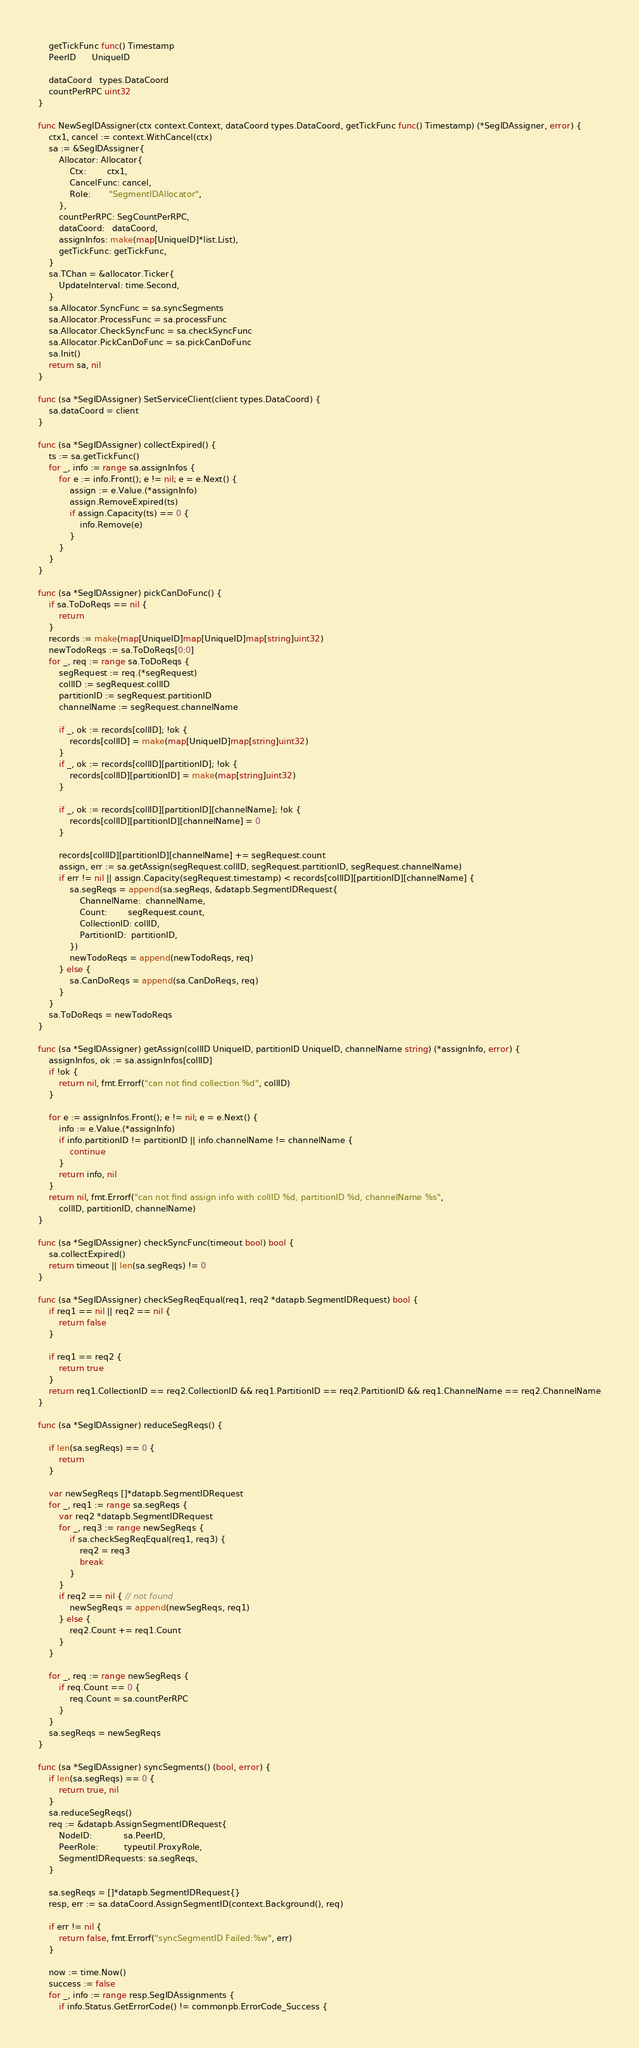Convert code to text. <code><loc_0><loc_0><loc_500><loc_500><_Go_>	getTickFunc func() Timestamp
	PeerID      UniqueID

	dataCoord   types.DataCoord
	countPerRPC uint32
}

func NewSegIDAssigner(ctx context.Context, dataCoord types.DataCoord, getTickFunc func() Timestamp) (*SegIDAssigner, error) {
	ctx1, cancel := context.WithCancel(ctx)
	sa := &SegIDAssigner{
		Allocator: Allocator{
			Ctx:        ctx1,
			CancelFunc: cancel,
			Role:       "SegmentIDAllocator",
		},
		countPerRPC: SegCountPerRPC,
		dataCoord:   dataCoord,
		assignInfos: make(map[UniqueID]*list.List),
		getTickFunc: getTickFunc,
	}
	sa.TChan = &allocator.Ticker{
		UpdateInterval: time.Second,
	}
	sa.Allocator.SyncFunc = sa.syncSegments
	sa.Allocator.ProcessFunc = sa.processFunc
	sa.Allocator.CheckSyncFunc = sa.checkSyncFunc
	sa.Allocator.PickCanDoFunc = sa.pickCanDoFunc
	sa.Init()
	return sa, nil
}

func (sa *SegIDAssigner) SetServiceClient(client types.DataCoord) {
	sa.dataCoord = client
}

func (sa *SegIDAssigner) collectExpired() {
	ts := sa.getTickFunc()
	for _, info := range sa.assignInfos {
		for e := info.Front(); e != nil; e = e.Next() {
			assign := e.Value.(*assignInfo)
			assign.RemoveExpired(ts)
			if assign.Capacity(ts) == 0 {
				info.Remove(e)
			}
		}
	}
}

func (sa *SegIDAssigner) pickCanDoFunc() {
	if sa.ToDoReqs == nil {
		return
	}
	records := make(map[UniqueID]map[UniqueID]map[string]uint32)
	newTodoReqs := sa.ToDoReqs[0:0]
	for _, req := range sa.ToDoReqs {
		segRequest := req.(*segRequest)
		collID := segRequest.collID
		partitionID := segRequest.partitionID
		channelName := segRequest.channelName

		if _, ok := records[collID]; !ok {
			records[collID] = make(map[UniqueID]map[string]uint32)
		}
		if _, ok := records[collID][partitionID]; !ok {
			records[collID][partitionID] = make(map[string]uint32)
		}

		if _, ok := records[collID][partitionID][channelName]; !ok {
			records[collID][partitionID][channelName] = 0
		}

		records[collID][partitionID][channelName] += segRequest.count
		assign, err := sa.getAssign(segRequest.collID, segRequest.partitionID, segRequest.channelName)
		if err != nil || assign.Capacity(segRequest.timestamp) < records[collID][partitionID][channelName] {
			sa.segReqs = append(sa.segReqs, &datapb.SegmentIDRequest{
				ChannelName:  channelName,
				Count:        segRequest.count,
				CollectionID: collID,
				PartitionID:  partitionID,
			})
			newTodoReqs = append(newTodoReqs, req)
		} else {
			sa.CanDoReqs = append(sa.CanDoReqs, req)
		}
	}
	sa.ToDoReqs = newTodoReqs
}

func (sa *SegIDAssigner) getAssign(collID UniqueID, partitionID UniqueID, channelName string) (*assignInfo, error) {
	assignInfos, ok := sa.assignInfos[collID]
	if !ok {
		return nil, fmt.Errorf("can not find collection %d", collID)
	}

	for e := assignInfos.Front(); e != nil; e = e.Next() {
		info := e.Value.(*assignInfo)
		if info.partitionID != partitionID || info.channelName != channelName {
			continue
		}
		return info, nil
	}
	return nil, fmt.Errorf("can not find assign info with collID %d, partitionID %d, channelName %s",
		collID, partitionID, channelName)
}

func (sa *SegIDAssigner) checkSyncFunc(timeout bool) bool {
	sa.collectExpired()
	return timeout || len(sa.segReqs) != 0
}

func (sa *SegIDAssigner) checkSegReqEqual(req1, req2 *datapb.SegmentIDRequest) bool {
	if req1 == nil || req2 == nil {
		return false
	}

	if req1 == req2 {
		return true
	}
	return req1.CollectionID == req2.CollectionID && req1.PartitionID == req2.PartitionID && req1.ChannelName == req2.ChannelName
}

func (sa *SegIDAssigner) reduceSegReqs() {

	if len(sa.segReqs) == 0 {
		return
	}

	var newSegReqs []*datapb.SegmentIDRequest
	for _, req1 := range sa.segReqs {
		var req2 *datapb.SegmentIDRequest
		for _, req3 := range newSegReqs {
			if sa.checkSegReqEqual(req1, req3) {
				req2 = req3
				break
			}
		}
		if req2 == nil { // not found
			newSegReqs = append(newSegReqs, req1)
		} else {
			req2.Count += req1.Count
		}
	}

	for _, req := range newSegReqs {
		if req.Count == 0 {
			req.Count = sa.countPerRPC
		}
	}
	sa.segReqs = newSegReqs
}

func (sa *SegIDAssigner) syncSegments() (bool, error) {
	if len(sa.segReqs) == 0 {
		return true, nil
	}
	sa.reduceSegReqs()
	req := &datapb.AssignSegmentIDRequest{
		NodeID:            sa.PeerID,
		PeerRole:          typeutil.ProxyRole,
		SegmentIDRequests: sa.segReqs,
	}

	sa.segReqs = []*datapb.SegmentIDRequest{}
	resp, err := sa.dataCoord.AssignSegmentID(context.Background(), req)

	if err != nil {
		return false, fmt.Errorf("syncSegmentID Failed:%w", err)
	}

	now := time.Now()
	success := false
	for _, info := range resp.SegIDAssignments {
		if info.Status.GetErrorCode() != commonpb.ErrorCode_Success {</code> 